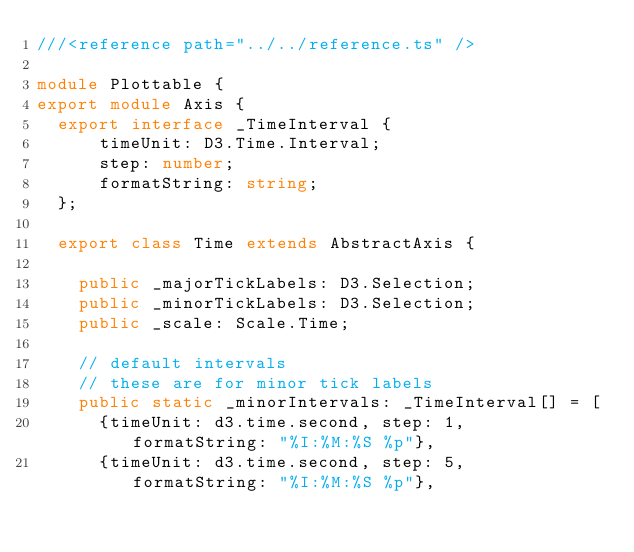<code> <loc_0><loc_0><loc_500><loc_500><_TypeScript_>///<reference path="../../reference.ts" />

module Plottable {
export module Axis {
  export interface _TimeInterval {
      timeUnit: D3.Time.Interval;
      step: number;
      formatString: string;
  };

  export class Time extends AbstractAxis {

    public _majorTickLabels: D3.Selection;
    public _minorTickLabels: D3.Selection;
    public _scale: Scale.Time;

    // default intervals
    // these are for minor tick labels
    public static _minorIntervals: _TimeInterval[] = [
      {timeUnit: d3.time.second, step: 1,      formatString: "%I:%M:%S %p"},
      {timeUnit: d3.time.second, step: 5,      formatString: "%I:%M:%S %p"},</code> 